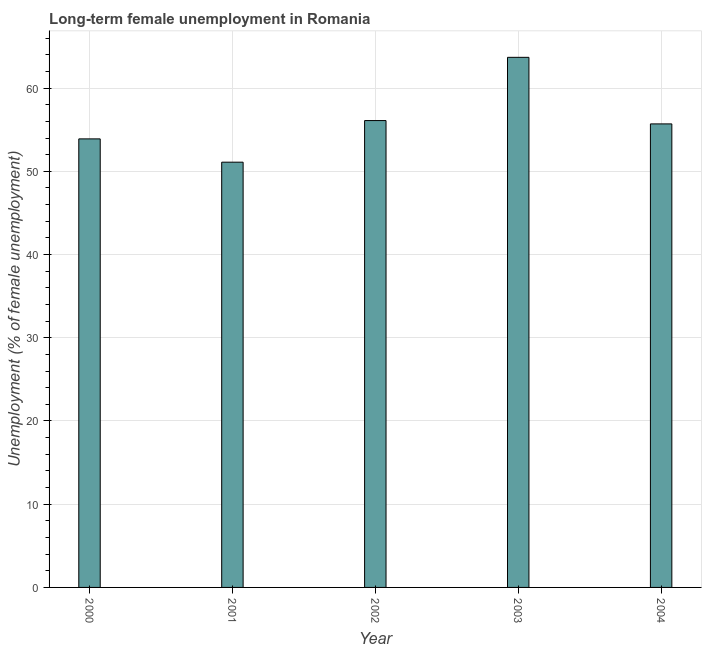Does the graph contain any zero values?
Your answer should be compact. No. Does the graph contain grids?
Your response must be concise. Yes. What is the title of the graph?
Give a very brief answer. Long-term female unemployment in Romania. What is the label or title of the Y-axis?
Your answer should be very brief. Unemployment (% of female unemployment). What is the long-term female unemployment in 2002?
Provide a short and direct response. 56.1. Across all years, what is the maximum long-term female unemployment?
Your response must be concise. 63.7. Across all years, what is the minimum long-term female unemployment?
Keep it short and to the point. 51.1. What is the sum of the long-term female unemployment?
Provide a succinct answer. 280.5. What is the difference between the long-term female unemployment in 2001 and 2002?
Ensure brevity in your answer.  -5. What is the average long-term female unemployment per year?
Make the answer very short. 56.1. What is the median long-term female unemployment?
Ensure brevity in your answer.  55.7. Do a majority of the years between 2003 and 2001 (inclusive) have long-term female unemployment greater than 62 %?
Make the answer very short. Yes. What is the ratio of the long-term female unemployment in 2002 to that in 2004?
Keep it short and to the point. 1.01. Is the long-term female unemployment in 2001 less than that in 2002?
Your response must be concise. Yes. Is the difference between the long-term female unemployment in 2001 and 2002 greater than the difference between any two years?
Give a very brief answer. No. Is the sum of the long-term female unemployment in 2002 and 2003 greater than the maximum long-term female unemployment across all years?
Your answer should be very brief. Yes. What is the difference between the highest and the lowest long-term female unemployment?
Ensure brevity in your answer.  12.6. Are all the bars in the graph horizontal?
Provide a short and direct response. No. How many years are there in the graph?
Ensure brevity in your answer.  5. What is the Unemployment (% of female unemployment) of 2000?
Ensure brevity in your answer.  53.9. What is the Unemployment (% of female unemployment) of 2001?
Make the answer very short. 51.1. What is the Unemployment (% of female unemployment) in 2002?
Keep it short and to the point. 56.1. What is the Unemployment (% of female unemployment) in 2003?
Make the answer very short. 63.7. What is the Unemployment (% of female unemployment) in 2004?
Provide a short and direct response. 55.7. What is the difference between the Unemployment (% of female unemployment) in 2000 and 2001?
Provide a short and direct response. 2.8. What is the difference between the Unemployment (% of female unemployment) in 2002 and 2003?
Provide a short and direct response. -7.6. What is the difference between the Unemployment (% of female unemployment) in 2002 and 2004?
Give a very brief answer. 0.4. What is the difference between the Unemployment (% of female unemployment) in 2003 and 2004?
Provide a short and direct response. 8. What is the ratio of the Unemployment (% of female unemployment) in 2000 to that in 2001?
Offer a very short reply. 1.05. What is the ratio of the Unemployment (% of female unemployment) in 2000 to that in 2002?
Provide a short and direct response. 0.96. What is the ratio of the Unemployment (% of female unemployment) in 2000 to that in 2003?
Your answer should be compact. 0.85. What is the ratio of the Unemployment (% of female unemployment) in 2000 to that in 2004?
Ensure brevity in your answer.  0.97. What is the ratio of the Unemployment (% of female unemployment) in 2001 to that in 2002?
Offer a terse response. 0.91. What is the ratio of the Unemployment (% of female unemployment) in 2001 to that in 2003?
Keep it short and to the point. 0.8. What is the ratio of the Unemployment (% of female unemployment) in 2001 to that in 2004?
Provide a succinct answer. 0.92. What is the ratio of the Unemployment (% of female unemployment) in 2002 to that in 2003?
Give a very brief answer. 0.88. What is the ratio of the Unemployment (% of female unemployment) in 2002 to that in 2004?
Give a very brief answer. 1.01. What is the ratio of the Unemployment (% of female unemployment) in 2003 to that in 2004?
Ensure brevity in your answer.  1.14. 